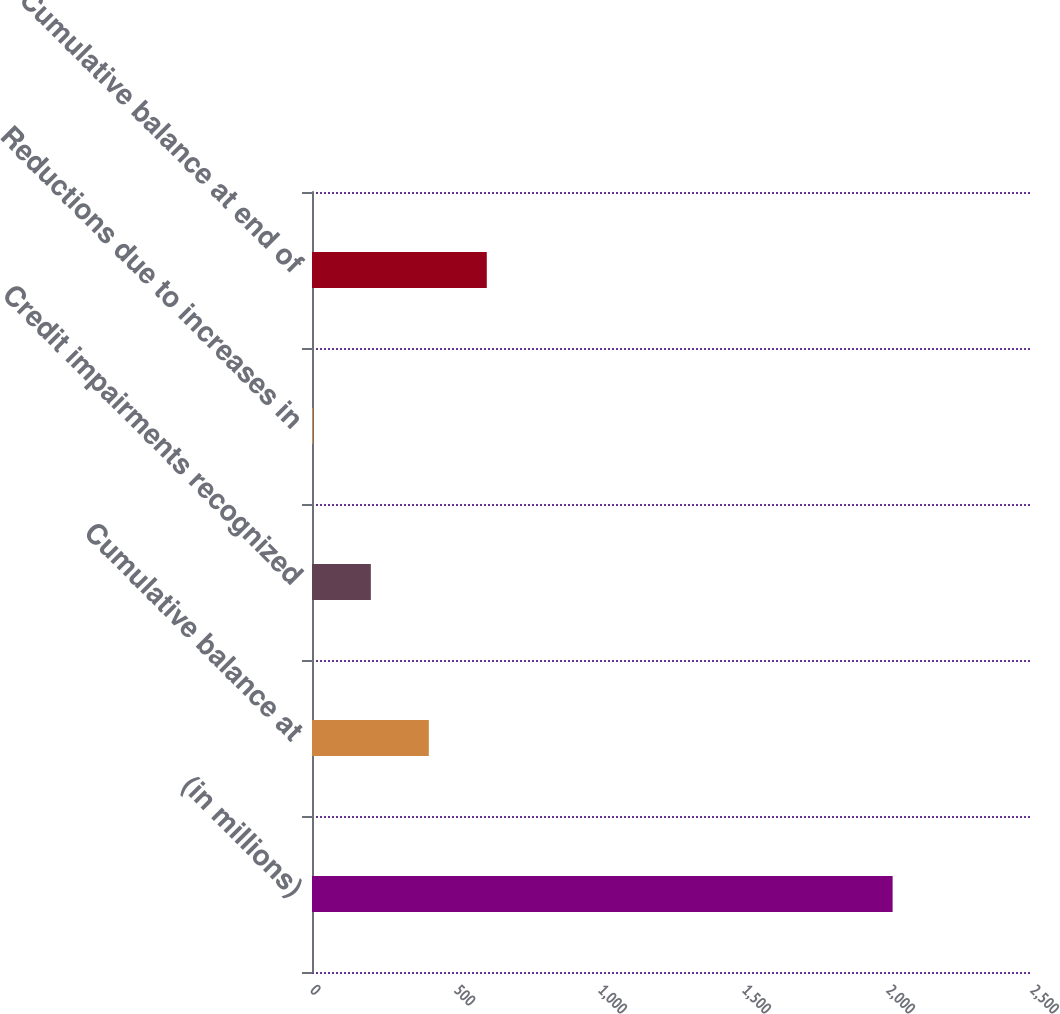Convert chart. <chart><loc_0><loc_0><loc_500><loc_500><bar_chart><fcel>(in millions)<fcel>Cumulative balance at<fcel>Credit impairments recognized<fcel>Reductions due to increases in<fcel>Cumulative balance at end of<nl><fcel>2016<fcel>405.6<fcel>204.3<fcel>3<fcel>606.9<nl></chart> 